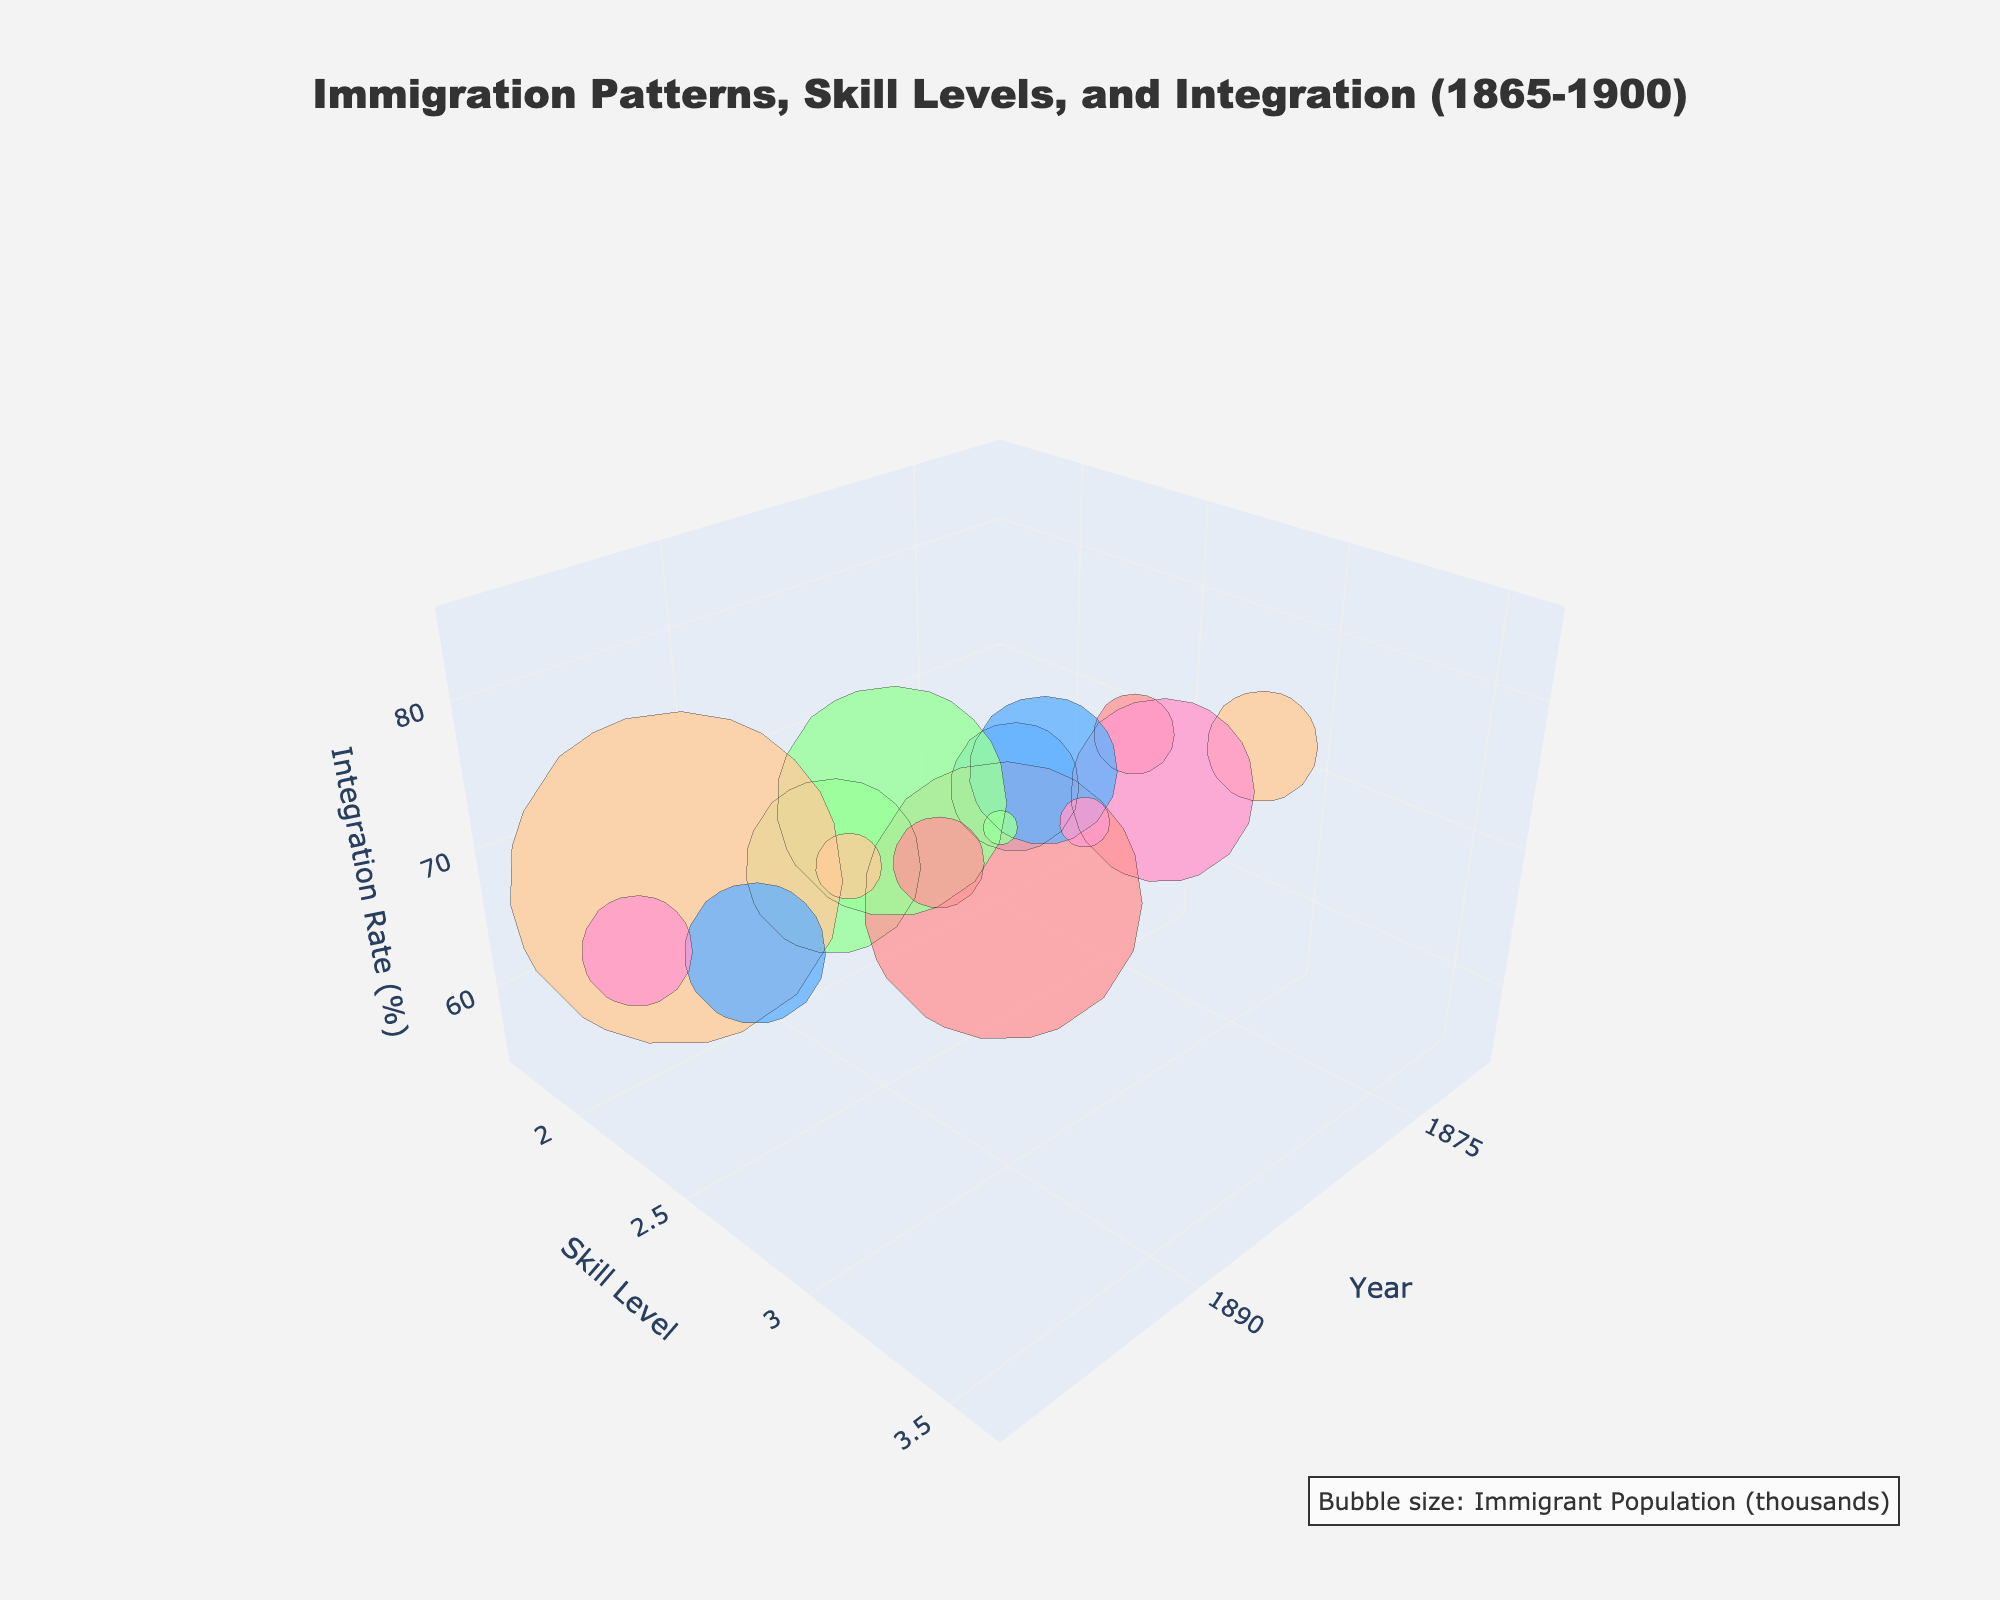What's the title of the figure? The title is located at the top of the figure and is bold and larger than other texts. It reads: 'Immigration Patterns, Skill Levels, and Integration (1865-1900)'.
Answer: Immigration Patterns, Skill Levels, and Integration (1865-1900) How many bubbles are displayed in the figure? Each bubble represents a data point and corresponds to a region-sector-year combination. By counting each data point from the data provided, there are 15 bubbles.
Answer: 15 In which year is the skill level the highest? Identify the year where the y-axis, which represents the skill level, has the highest value across all bubbles. This occurs in the year 1900 for the Mid-Atlantic, Steel Production sector, with a skill level of 3.6.
Answer: 1900 Which sector has the largest immigrant population in 1900 while having the lowest integration rate? Compare the size and position of bubbles in the year 1900. Look for the bubble furthest to the left on the integration rate (z-axis), which is for the South, Cotton Processing sector with an immigrant population of 62,000 and an integration rate of 69%.
Answer: Cotton Processing What's the integration rate range across all displayed bubbles? The integration rate (z-axis) ranges from the minimum integration rate of 55% to the maximum integration rate of 85% based on the values given in the data.
Answer: 55% to 85% By how much does the skill level increase in Textile Manufacturing from 1870 to 1900? Find the skill levels for Textile Manufacturing in 1870 and 1900, then subtract the value in 1870 from the value in 1900. The increase is 3.1 - 2.3 = 0.8.
Answer: 0.8 Which region's sector has the smallest bubble size in the figure? The bubble size corresponds to the immigrant population. The smallest population, 19,000 in 1870, is for the South, Cotton Processing sector.
Answer: South, Cotton Processing Which region has the highest integration rate in 1885? Isolate the 1885 data points, then identify the maximum z-axis value. The Mid-Atlantic, Steel Production sector has the highest integration rate of 79% in 1885.
Answer: Mid-Atlantic, Steel Production What's the total immigrant population for all sectors in 1870? Sum the immigrant populations for all sectors in 1870: New England 45,000 + Mid-Atlantic 62,000 + Midwest 83,000 + West Coast 28,000 + South 19,000 = 237,000.
Answer: 237,000 Compare the integration rate in Textile Manufacturing and Mining in 1900. Which one is higher? Check the z-axis values for Textile Manufacturing in New England and Mining on the West Coast in 1900. Integration rates are 82% and 74%, respectively. Textile Manufacturing has a higher integration rate.
Answer: Textile Manufacturing 